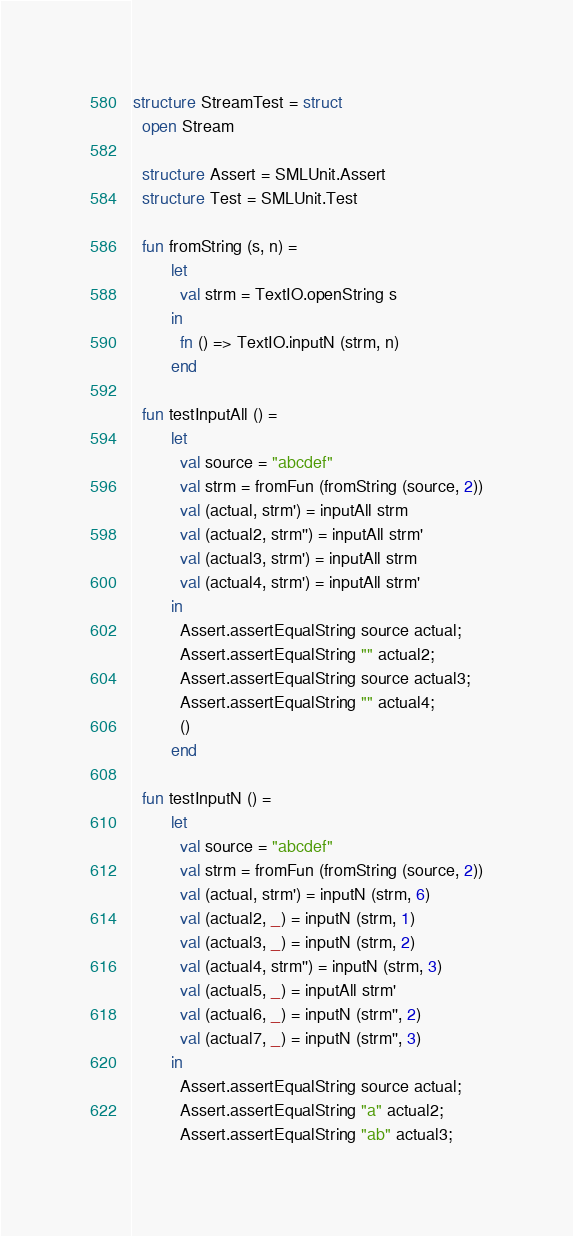<code> <loc_0><loc_0><loc_500><loc_500><_SML_>structure StreamTest = struct
  open Stream

  structure Assert = SMLUnit.Assert
  structure Test = SMLUnit.Test

  fun fromString (s, n) =
        let
          val strm = TextIO.openString s
        in
          fn () => TextIO.inputN (strm, n)
        end

  fun testInputAll () =
        let
          val source = "abcdef"
          val strm = fromFun (fromString (source, 2))
          val (actual, strm') = inputAll strm
          val (actual2, strm'') = inputAll strm'
          val (actual3, strm') = inputAll strm
          val (actual4, strm') = inputAll strm'
        in
          Assert.assertEqualString source actual;
          Assert.assertEqualString "" actual2;
          Assert.assertEqualString source actual3;
          Assert.assertEqualString "" actual4;
          ()
        end

  fun testInputN () =
        let
          val source = "abcdef"
          val strm = fromFun (fromString (source, 2))
          val (actual, strm') = inputN (strm, 6)
          val (actual2, _) = inputN (strm, 1)
          val (actual3, _) = inputN (strm, 2)
          val (actual4, strm'') = inputN (strm, 3)
          val (actual5, _) = inputAll strm'
          val (actual6, _) = inputN (strm'', 2)
          val (actual7, _) = inputN (strm'', 3)
        in
          Assert.assertEqualString source actual;
          Assert.assertEqualString "a" actual2;
          Assert.assertEqualString "ab" actual3;</code> 